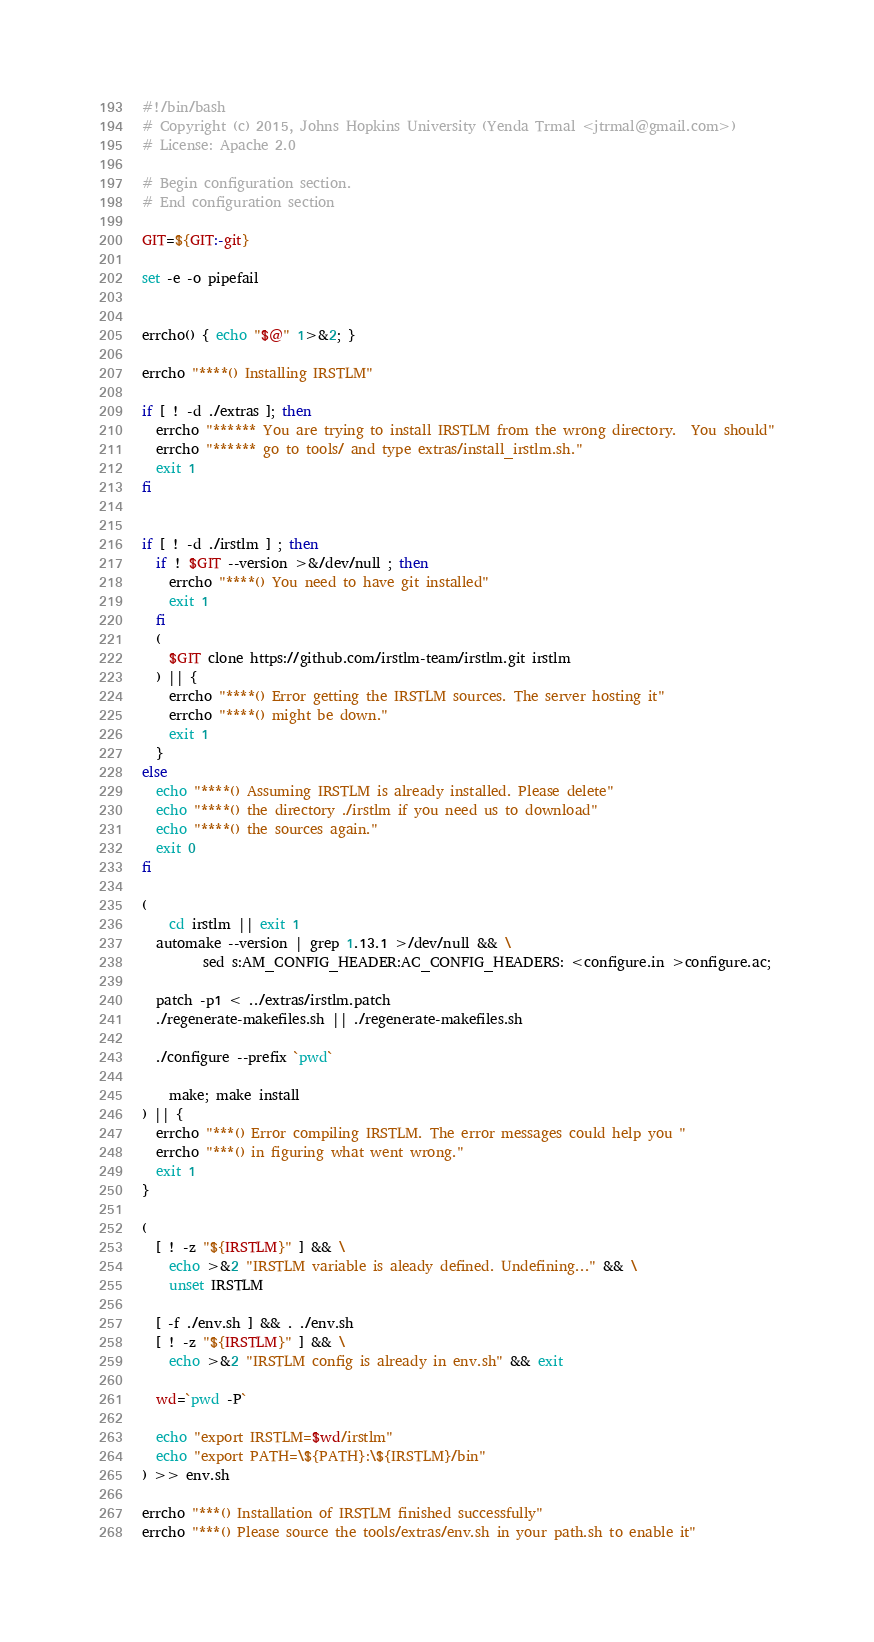<code> <loc_0><loc_0><loc_500><loc_500><_Bash_>#!/bin/bash
# Copyright (c) 2015, Johns Hopkins University (Yenda Trmal <jtrmal@gmail.com>)
# License: Apache 2.0

# Begin configuration section.
# End configuration section

GIT=${GIT:-git}

set -e -o pipefail


errcho() { echo "$@" 1>&2; }

errcho "****() Installing IRSTLM"

if [ ! -d ./extras ]; then
  errcho "****** You are trying to install IRSTLM from the wrong directory.  You should"
  errcho "****** go to tools/ and type extras/install_irstlm.sh."
  exit 1
fi


if [ ! -d ./irstlm ] ; then
  if ! $GIT --version >&/dev/null ; then
    errcho "****() You need to have git installed"
    exit 1
  fi
  (
    $GIT clone https://github.com/irstlm-team/irstlm.git irstlm
  ) || {
    errcho "****() Error getting the IRSTLM sources. The server hosting it"
    errcho "****() might be down."
    exit 1
  }
else
  echo "****() Assuming IRSTLM is already installed. Please delete"
  echo "****() the directory ./irstlm if you need us to download"
  echo "****() the sources again."
  exit 0
fi

(
	cd irstlm || exit 1
  automake --version | grep 1.13.1 >/dev/null && \
         sed s:AM_CONFIG_HEADER:AC_CONFIG_HEADERS: <configure.in >configure.ac;

  patch -p1 < ../extras/irstlm.patch
  ./regenerate-makefiles.sh || ./regenerate-makefiles.sh

  ./configure --prefix `pwd`

	make; make install
) || {
  errcho "***() Error compiling IRSTLM. The error messages could help you "
  errcho "***() in figuring what went wrong."
  exit 1
}

(
  [ ! -z "${IRSTLM}" ] && \
    echo >&2 "IRSTLM variable is aleady defined. Undefining..." && \
    unset IRSTLM

  [ -f ./env.sh ] && . ./env.sh
  [ ! -z "${IRSTLM}" ] && \
    echo >&2 "IRSTLM config is already in env.sh" && exit

  wd=`pwd -P`

  echo "export IRSTLM=$wd/irstlm"
  echo "export PATH=\${PATH}:\${IRSTLM}/bin"
) >> env.sh

errcho "***() Installation of IRSTLM finished successfully"
errcho "***() Please source the tools/extras/env.sh in your path.sh to enable it"
</code> 